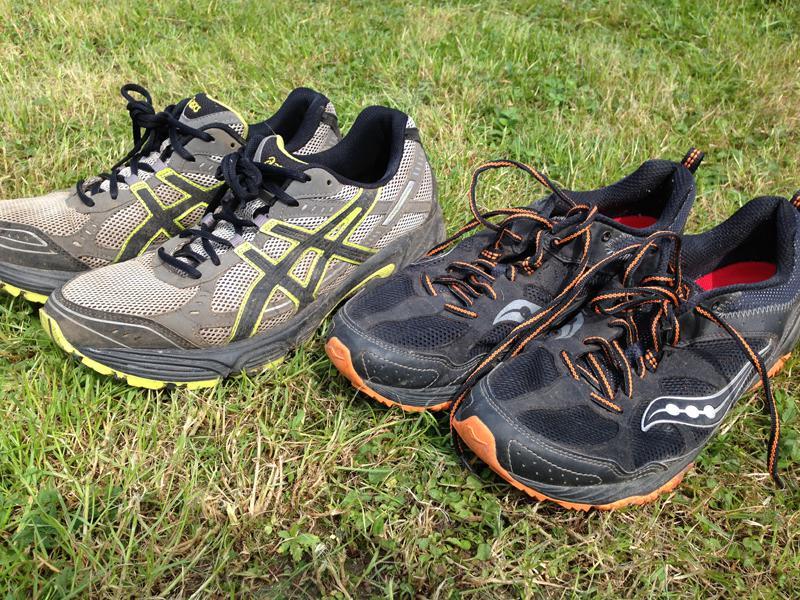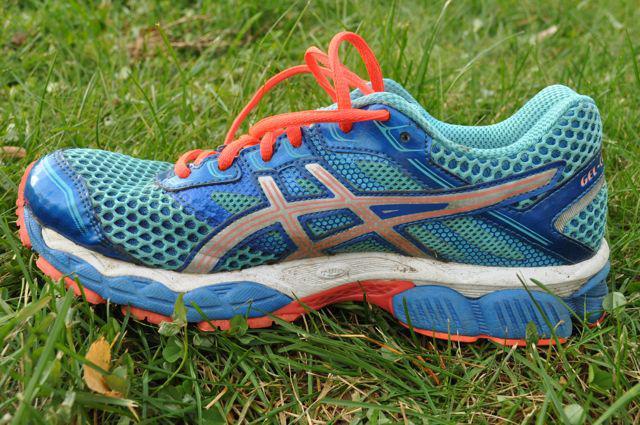The first image is the image on the left, the second image is the image on the right. Given the left and right images, does the statement "There are 2 shoes facing to the right." hold true? Answer yes or no. No. 